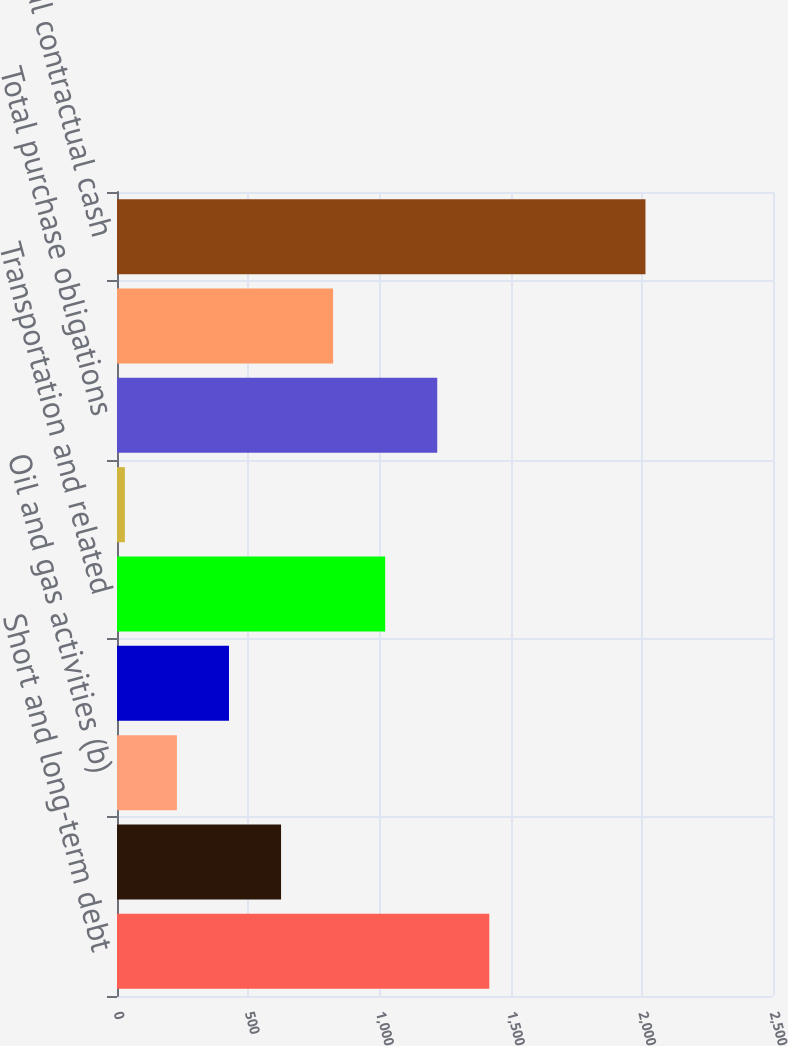<chart> <loc_0><loc_0><loc_500><loc_500><bar_chart><fcel>Short and long-term debt<fcel>Lease obligations<fcel>Oil and gas activities (b)<fcel>Service and materials<fcel>Transportation and related<fcel>Other (g)<fcel>Total purchase obligations<fcel>Other long-term liabilities<fcel>Total contractual cash<nl><fcel>1418.8<fcel>625.2<fcel>228.4<fcel>426.8<fcel>1022<fcel>30<fcel>1220.4<fcel>823.6<fcel>2014<nl></chart> 